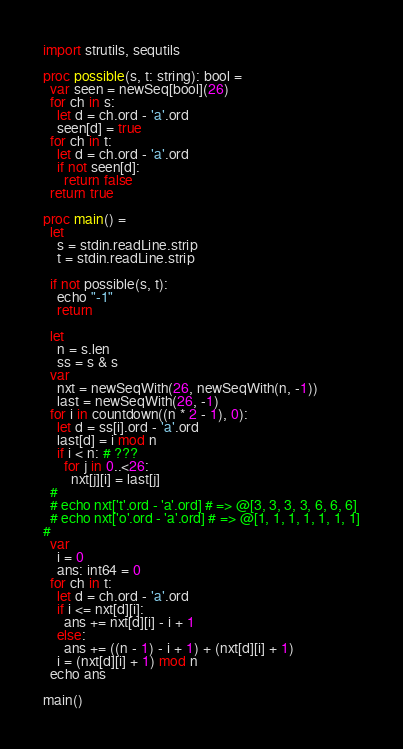Convert code to text. <code><loc_0><loc_0><loc_500><loc_500><_Nim_>import strutils, sequtils

proc possible(s, t: string): bool =
  var seen = newSeq[bool](26)
  for ch in s:
    let d = ch.ord - 'a'.ord
    seen[d] = true
  for ch in t:
    let d = ch.ord - 'a'.ord
    if not seen[d]:
      return false
  return true

proc main() =
  let
    s = stdin.readLine.strip
    t = stdin.readLine.strip

  if not possible(s, t):
    echo "-1"
    return

  let
    n = s.len
    ss = s & s
  var
    nxt = newSeqWith(26, newSeqWith(n, -1))
    last = newSeqWith(26, -1)
  for i in countdown((n * 2 - 1), 0):
    let d = ss[i].ord - 'a'.ord
    last[d] = i mod n
    if i < n: # ???
      for j in 0..<26:
        nxt[j][i] = last[j]
  #
  # echo nxt['t'.ord - 'a'.ord] # => @[3, 3, 3, 3, 6, 6, 6]
  # echo nxt['o'.ord - 'a'.ord] # => @[1, 1, 1, 1, 1, 1, 1]
#
  var
    i = 0
    ans: int64 = 0
  for ch in t:
    let d = ch.ord - 'a'.ord
    if i <= nxt[d][i]:
      ans += nxt[d][i] - i + 1
    else:
      ans += ((n - 1) - i + 1) + (nxt[d][i] + 1)
    i = (nxt[d][i] + 1) mod n
  echo ans

main()
</code> 